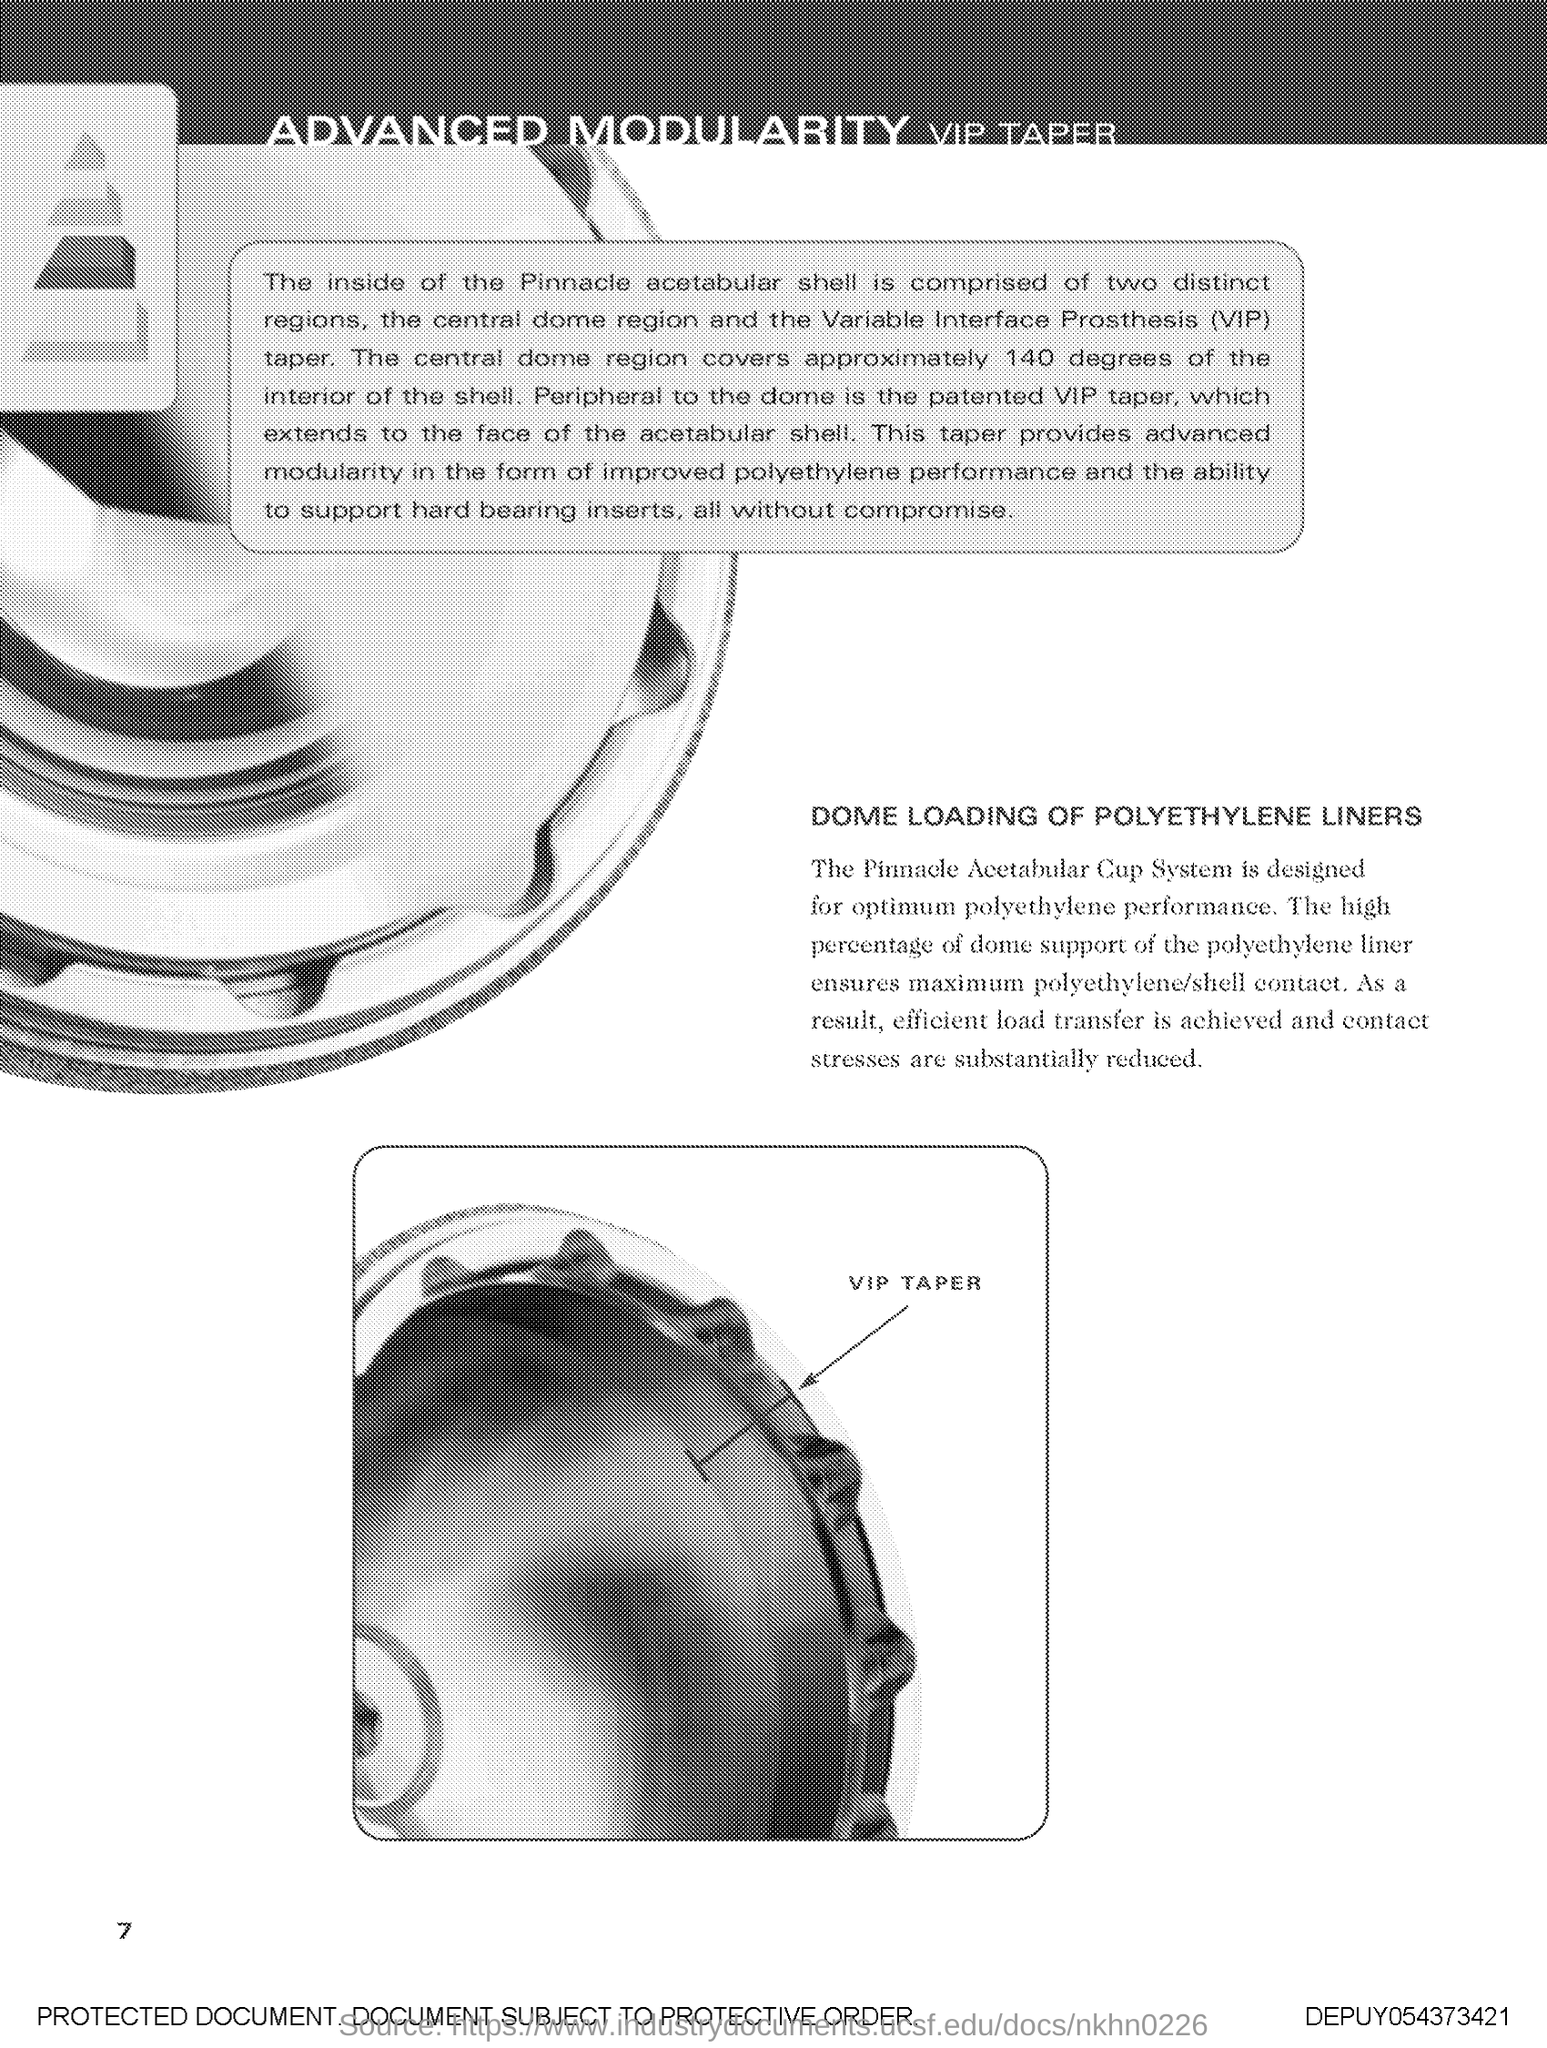Indicate a few pertinent items in this graphic. The Pinnacle acetabular shell has two distinct regions: the central dome region and the Variable interface Prosthesis (VIP) taper. The page number mentioned in this document is 7. The Pinnacle Acetabular Cup System is specifically engineered to deliver optimal performance when used with polyethylene components. The full form of VIP is Variable Interface Prosthesis, which refers to a type of medical device used to replace a damaged or missing body part. 